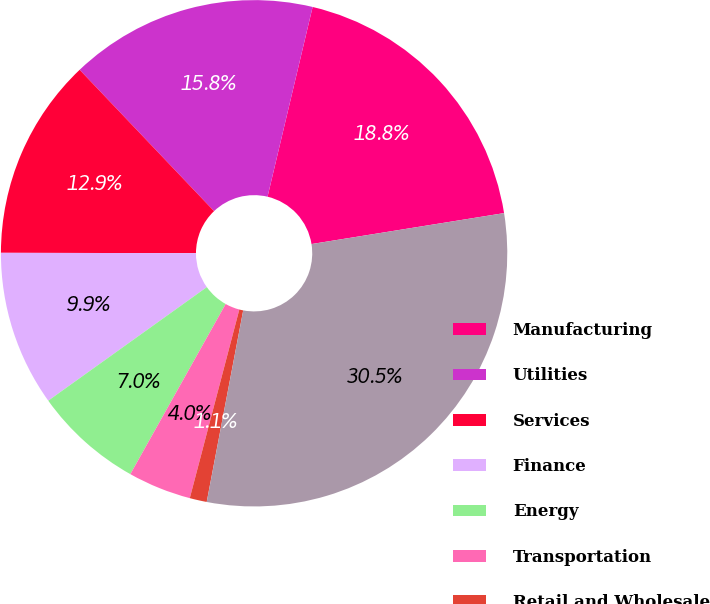Convert chart. <chart><loc_0><loc_0><loc_500><loc_500><pie_chart><fcel>Manufacturing<fcel>Utilities<fcel>Services<fcel>Finance<fcel>Energy<fcel>Transportation<fcel>Retail and Wholesale<fcel>Total Corporate Securities<nl><fcel>18.75%<fcel>15.81%<fcel>12.87%<fcel>9.92%<fcel>6.98%<fcel>4.04%<fcel>1.09%<fcel>30.53%<nl></chart> 